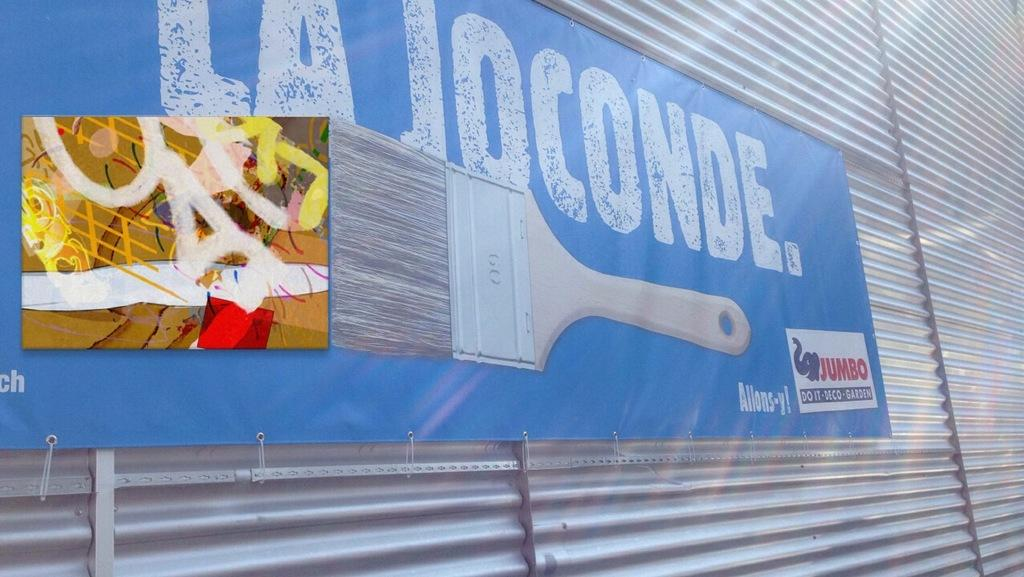<image>
Offer a succinct explanation of the picture presented. A La Joconde billboard shows a large paint brush. 